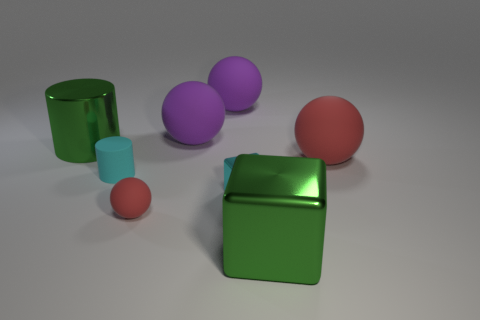Add 2 green matte balls. How many objects exist? 10 Subtract all large red rubber spheres. How many spheres are left? 3 Subtract all red balls. How many balls are left? 2 Subtract 1 cubes. How many cubes are left? 1 Subtract all green cylinders. How many red balls are left? 2 Subtract all cylinders. How many objects are left? 6 Add 8 big brown shiny objects. How many big brown shiny objects exist? 8 Subtract 0 blue cylinders. How many objects are left? 8 Subtract all brown blocks. Subtract all blue balls. How many blocks are left? 2 Subtract all cubes. Subtract all brown rubber cylinders. How many objects are left? 6 